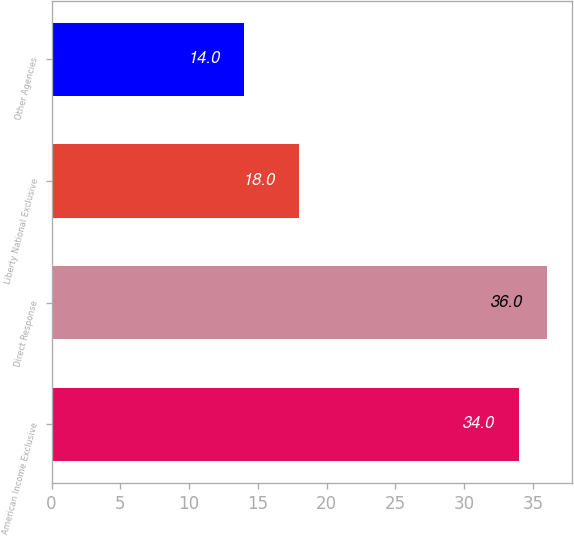Convert chart. <chart><loc_0><loc_0><loc_500><loc_500><bar_chart><fcel>American Income Exclusive<fcel>Direct Response<fcel>Liberty National Exclusive<fcel>Other Agencies<nl><fcel>34<fcel>36<fcel>18<fcel>14<nl></chart> 